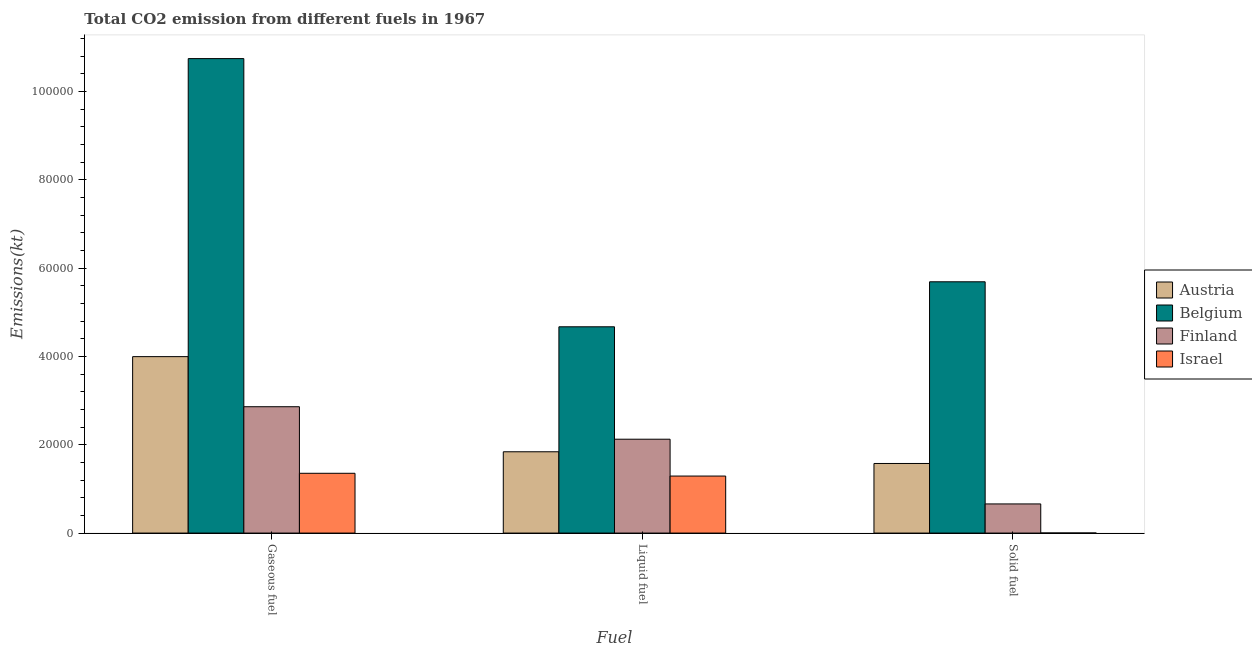How many groups of bars are there?
Make the answer very short. 3. Are the number of bars on each tick of the X-axis equal?
Your answer should be compact. Yes. What is the label of the 2nd group of bars from the left?
Give a very brief answer. Liquid fuel. What is the amount of co2 emissions from liquid fuel in Finland?
Ensure brevity in your answer.  2.13e+04. Across all countries, what is the maximum amount of co2 emissions from liquid fuel?
Your answer should be compact. 4.67e+04. Across all countries, what is the minimum amount of co2 emissions from solid fuel?
Your response must be concise. 18.34. In which country was the amount of co2 emissions from liquid fuel maximum?
Ensure brevity in your answer.  Belgium. What is the total amount of co2 emissions from gaseous fuel in the graph?
Offer a very short reply. 1.90e+05. What is the difference between the amount of co2 emissions from liquid fuel in Israel and that in Austria?
Ensure brevity in your answer.  -5500.5. What is the difference between the amount of co2 emissions from gaseous fuel in Israel and the amount of co2 emissions from solid fuel in Finland?
Provide a succinct answer. 6941.63. What is the average amount of co2 emissions from liquid fuel per country?
Offer a terse response. 2.48e+04. What is the difference between the amount of co2 emissions from solid fuel and amount of co2 emissions from liquid fuel in Israel?
Keep it short and to the point. -1.29e+04. In how many countries, is the amount of co2 emissions from gaseous fuel greater than 32000 kt?
Ensure brevity in your answer.  2. What is the ratio of the amount of co2 emissions from solid fuel in Finland to that in Israel?
Your answer should be compact. 360. Is the amount of co2 emissions from solid fuel in Austria less than that in Israel?
Your answer should be very brief. No. What is the difference between the highest and the second highest amount of co2 emissions from solid fuel?
Ensure brevity in your answer.  4.12e+04. What is the difference between the highest and the lowest amount of co2 emissions from gaseous fuel?
Make the answer very short. 9.39e+04. What does the 4th bar from the left in Liquid fuel represents?
Offer a terse response. Israel. What does the 1st bar from the right in Liquid fuel represents?
Provide a short and direct response. Israel. How many bars are there?
Your answer should be compact. 12. What is the difference between two consecutive major ticks on the Y-axis?
Your answer should be very brief. 2.00e+04. Are the values on the major ticks of Y-axis written in scientific E-notation?
Your response must be concise. No. Does the graph contain any zero values?
Offer a very short reply. No. Does the graph contain grids?
Offer a terse response. No. Where does the legend appear in the graph?
Keep it short and to the point. Center right. What is the title of the graph?
Offer a very short reply. Total CO2 emission from different fuels in 1967. Does "St. Martin (French part)" appear as one of the legend labels in the graph?
Offer a very short reply. No. What is the label or title of the X-axis?
Ensure brevity in your answer.  Fuel. What is the label or title of the Y-axis?
Provide a short and direct response. Emissions(kt). What is the Emissions(kt) in Austria in Gaseous fuel?
Provide a short and direct response. 4.00e+04. What is the Emissions(kt) in Belgium in Gaseous fuel?
Make the answer very short. 1.07e+05. What is the Emissions(kt) of Finland in Gaseous fuel?
Keep it short and to the point. 2.86e+04. What is the Emissions(kt) of Israel in Gaseous fuel?
Keep it short and to the point. 1.35e+04. What is the Emissions(kt) of Austria in Liquid fuel?
Ensure brevity in your answer.  1.84e+04. What is the Emissions(kt) in Belgium in Liquid fuel?
Provide a succinct answer. 4.67e+04. What is the Emissions(kt) of Finland in Liquid fuel?
Offer a very short reply. 2.13e+04. What is the Emissions(kt) in Israel in Liquid fuel?
Give a very brief answer. 1.29e+04. What is the Emissions(kt) of Austria in Solid fuel?
Your answer should be very brief. 1.58e+04. What is the Emissions(kt) of Belgium in Solid fuel?
Ensure brevity in your answer.  5.69e+04. What is the Emissions(kt) in Finland in Solid fuel?
Provide a succinct answer. 6600.6. What is the Emissions(kt) in Israel in Solid fuel?
Make the answer very short. 18.34. Across all Fuel, what is the maximum Emissions(kt) in Austria?
Provide a succinct answer. 4.00e+04. Across all Fuel, what is the maximum Emissions(kt) of Belgium?
Ensure brevity in your answer.  1.07e+05. Across all Fuel, what is the maximum Emissions(kt) in Finland?
Make the answer very short. 2.86e+04. Across all Fuel, what is the maximum Emissions(kt) in Israel?
Offer a terse response. 1.35e+04. Across all Fuel, what is the minimum Emissions(kt) of Austria?
Your response must be concise. 1.58e+04. Across all Fuel, what is the minimum Emissions(kt) in Belgium?
Ensure brevity in your answer.  4.67e+04. Across all Fuel, what is the minimum Emissions(kt) in Finland?
Your answer should be very brief. 6600.6. Across all Fuel, what is the minimum Emissions(kt) in Israel?
Your response must be concise. 18.34. What is the total Emissions(kt) in Austria in the graph?
Offer a terse response. 7.41e+04. What is the total Emissions(kt) in Belgium in the graph?
Your answer should be compact. 2.11e+05. What is the total Emissions(kt) in Finland in the graph?
Give a very brief answer. 5.65e+04. What is the total Emissions(kt) in Israel in the graph?
Offer a very short reply. 2.65e+04. What is the difference between the Emissions(kt) of Austria in Gaseous fuel and that in Liquid fuel?
Your response must be concise. 2.16e+04. What is the difference between the Emissions(kt) in Belgium in Gaseous fuel and that in Liquid fuel?
Your response must be concise. 6.07e+04. What is the difference between the Emissions(kt) of Finland in Gaseous fuel and that in Liquid fuel?
Give a very brief answer. 7356. What is the difference between the Emissions(kt) in Israel in Gaseous fuel and that in Liquid fuel?
Your answer should be compact. 627.06. What is the difference between the Emissions(kt) of Austria in Gaseous fuel and that in Solid fuel?
Your answer should be compact. 2.42e+04. What is the difference between the Emissions(kt) in Belgium in Gaseous fuel and that in Solid fuel?
Provide a succinct answer. 5.06e+04. What is the difference between the Emissions(kt) in Finland in Gaseous fuel and that in Solid fuel?
Offer a terse response. 2.20e+04. What is the difference between the Emissions(kt) of Israel in Gaseous fuel and that in Solid fuel?
Ensure brevity in your answer.  1.35e+04. What is the difference between the Emissions(kt) in Austria in Liquid fuel and that in Solid fuel?
Your answer should be very brief. 2651.24. What is the difference between the Emissions(kt) of Belgium in Liquid fuel and that in Solid fuel?
Provide a succinct answer. -1.02e+04. What is the difference between the Emissions(kt) in Finland in Liquid fuel and that in Solid fuel?
Provide a succinct answer. 1.47e+04. What is the difference between the Emissions(kt) in Israel in Liquid fuel and that in Solid fuel?
Your answer should be compact. 1.29e+04. What is the difference between the Emissions(kt) of Austria in Gaseous fuel and the Emissions(kt) of Belgium in Liquid fuel?
Provide a succinct answer. -6758.28. What is the difference between the Emissions(kt) of Austria in Gaseous fuel and the Emissions(kt) of Finland in Liquid fuel?
Provide a short and direct response. 1.87e+04. What is the difference between the Emissions(kt) of Austria in Gaseous fuel and the Emissions(kt) of Israel in Liquid fuel?
Your answer should be very brief. 2.71e+04. What is the difference between the Emissions(kt) in Belgium in Gaseous fuel and the Emissions(kt) in Finland in Liquid fuel?
Your answer should be very brief. 8.62e+04. What is the difference between the Emissions(kt) in Belgium in Gaseous fuel and the Emissions(kt) in Israel in Liquid fuel?
Offer a terse response. 9.46e+04. What is the difference between the Emissions(kt) of Finland in Gaseous fuel and the Emissions(kt) of Israel in Liquid fuel?
Make the answer very short. 1.57e+04. What is the difference between the Emissions(kt) of Austria in Gaseous fuel and the Emissions(kt) of Belgium in Solid fuel?
Ensure brevity in your answer.  -1.70e+04. What is the difference between the Emissions(kt) in Austria in Gaseous fuel and the Emissions(kt) in Finland in Solid fuel?
Keep it short and to the point. 3.34e+04. What is the difference between the Emissions(kt) of Austria in Gaseous fuel and the Emissions(kt) of Israel in Solid fuel?
Offer a terse response. 3.99e+04. What is the difference between the Emissions(kt) of Belgium in Gaseous fuel and the Emissions(kt) of Finland in Solid fuel?
Offer a very short reply. 1.01e+05. What is the difference between the Emissions(kt) of Belgium in Gaseous fuel and the Emissions(kt) of Israel in Solid fuel?
Make the answer very short. 1.07e+05. What is the difference between the Emissions(kt) of Finland in Gaseous fuel and the Emissions(kt) of Israel in Solid fuel?
Offer a very short reply. 2.86e+04. What is the difference between the Emissions(kt) in Austria in Liquid fuel and the Emissions(kt) in Belgium in Solid fuel?
Provide a short and direct response. -3.85e+04. What is the difference between the Emissions(kt) in Austria in Liquid fuel and the Emissions(kt) in Finland in Solid fuel?
Keep it short and to the point. 1.18e+04. What is the difference between the Emissions(kt) in Austria in Liquid fuel and the Emissions(kt) in Israel in Solid fuel?
Your response must be concise. 1.84e+04. What is the difference between the Emissions(kt) in Belgium in Liquid fuel and the Emissions(kt) in Finland in Solid fuel?
Offer a very short reply. 4.01e+04. What is the difference between the Emissions(kt) of Belgium in Liquid fuel and the Emissions(kt) of Israel in Solid fuel?
Give a very brief answer. 4.67e+04. What is the difference between the Emissions(kt) of Finland in Liquid fuel and the Emissions(kt) of Israel in Solid fuel?
Provide a succinct answer. 2.12e+04. What is the average Emissions(kt) in Austria per Fuel?
Keep it short and to the point. 2.47e+04. What is the average Emissions(kt) of Belgium per Fuel?
Your response must be concise. 7.04e+04. What is the average Emissions(kt) in Finland per Fuel?
Provide a succinct answer. 1.88e+04. What is the average Emissions(kt) of Israel per Fuel?
Offer a terse response. 8825.25. What is the difference between the Emissions(kt) of Austria and Emissions(kt) of Belgium in Gaseous fuel?
Provide a short and direct response. -6.75e+04. What is the difference between the Emissions(kt) of Austria and Emissions(kt) of Finland in Gaseous fuel?
Give a very brief answer. 1.13e+04. What is the difference between the Emissions(kt) of Austria and Emissions(kt) of Israel in Gaseous fuel?
Make the answer very short. 2.64e+04. What is the difference between the Emissions(kt) of Belgium and Emissions(kt) of Finland in Gaseous fuel?
Offer a very short reply. 7.89e+04. What is the difference between the Emissions(kt) of Belgium and Emissions(kt) of Israel in Gaseous fuel?
Provide a short and direct response. 9.39e+04. What is the difference between the Emissions(kt) in Finland and Emissions(kt) in Israel in Gaseous fuel?
Your response must be concise. 1.51e+04. What is the difference between the Emissions(kt) in Austria and Emissions(kt) in Belgium in Liquid fuel?
Keep it short and to the point. -2.83e+04. What is the difference between the Emissions(kt) of Austria and Emissions(kt) of Finland in Liquid fuel?
Offer a terse response. -2845.59. What is the difference between the Emissions(kt) of Austria and Emissions(kt) of Israel in Liquid fuel?
Your answer should be very brief. 5500.5. What is the difference between the Emissions(kt) of Belgium and Emissions(kt) of Finland in Liquid fuel?
Provide a succinct answer. 2.55e+04. What is the difference between the Emissions(kt) in Belgium and Emissions(kt) in Israel in Liquid fuel?
Ensure brevity in your answer.  3.38e+04. What is the difference between the Emissions(kt) in Finland and Emissions(kt) in Israel in Liquid fuel?
Offer a very short reply. 8346.09. What is the difference between the Emissions(kt) in Austria and Emissions(kt) in Belgium in Solid fuel?
Keep it short and to the point. -4.12e+04. What is the difference between the Emissions(kt) of Austria and Emissions(kt) of Finland in Solid fuel?
Make the answer very short. 9163.83. What is the difference between the Emissions(kt) in Austria and Emissions(kt) in Israel in Solid fuel?
Provide a short and direct response. 1.57e+04. What is the difference between the Emissions(kt) in Belgium and Emissions(kt) in Finland in Solid fuel?
Make the answer very short. 5.03e+04. What is the difference between the Emissions(kt) in Belgium and Emissions(kt) in Israel in Solid fuel?
Offer a terse response. 5.69e+04. What is the difference between the Emissions(kt) of Finland and Emissions(kt) of Israel in Solid fuel?
Ensure brevity in your answer.  6582.27. What is the ratio of the Emissions(kt) of Austria in Gaseous fuel to that in Liquid fuel?
Provide a succinct answer. 2.17. What is the ratio of the Emissions(kt) of Belgium in Gaseous fuel to that in Liquid fuel?
Ensure brevity in your answer.  2.3. What is the ratio of the Emissions(kt) in Finland in Gaseous fuel to that in Liquid fuel?
Offer a terse response. 1.35. What is the ratio of the Emissions(kt) in Israel in Gaseous fuel to that in Liquid fuel?
Keep it short and to the point. 1.05. What is the ratio of the Emissions(kt) in Austria in Gaseous fuel to that in Solid fuel?
Ensure brevity in your answer.  2.54. What is the ratio of the Emissions(kt) in Belgium in Gaseous fuel to that in Solid fuel?
Your response must be concise. 1.89. What is the ratio of the Emissions(kt) in Finland in Gaseous fuel to that in Solid fuel?
Your answer should be compact. 4.34. What is the ratio of the Emissions(kt) of Israel in Gaseous fuel to that in Solid fuel?
Give a very brief answer. 738.6. What is the ratio of the Emissions(kt) of Austria in Liquid fuel to that in Solid fuel?
Your answer should be compact. 1.17. What is the ratio of the Emissions(kt) of Belgium in Liquid fuel to that in Solid fuel?
Give a very brief answer. 0.82. What is the ratio of the Emissions(kt) in Finland in Liquid fuel to that in Solid fuel?
Your answer should be compact. 3.22. What is the ratio of the Emissions(kt) of Israel in Liquid fuel to that in Solid fuel?
Give a very brief answer. 704.4. What is the difference between the highest and the second highest Emissions(kt) in Austria?
Your answer should be compact. 2.16e+04. What is the difference between the highest and the second highest Emissions(kt) of Belgium?
Offer a very short reply. 5.06e+04. What is the difference between the highest and the second highest Emissions(kt) in Finland?
Offer a terse response. 7356. What is the difference between the highest and the second highest Emissions(kt) in Israel?
Make the answer very short. 627.06. What is the difference between the highest and the lowest Emissions(kt) of Austria?
Offer a terse response. 2.42e+04. What is the difference between the highest and the lowest Emissions(kt) in Belgium?
Ensure brevity in your answer.  6.07e+04. What is the difference between the highest and the lowest Emissions(kt) of Finland?
Offer a terse response. 2.20e+04. What is the difference between the highest and the lowest Emissions(kt) of Israel?
Offer a terse response. 1.35e+04. 